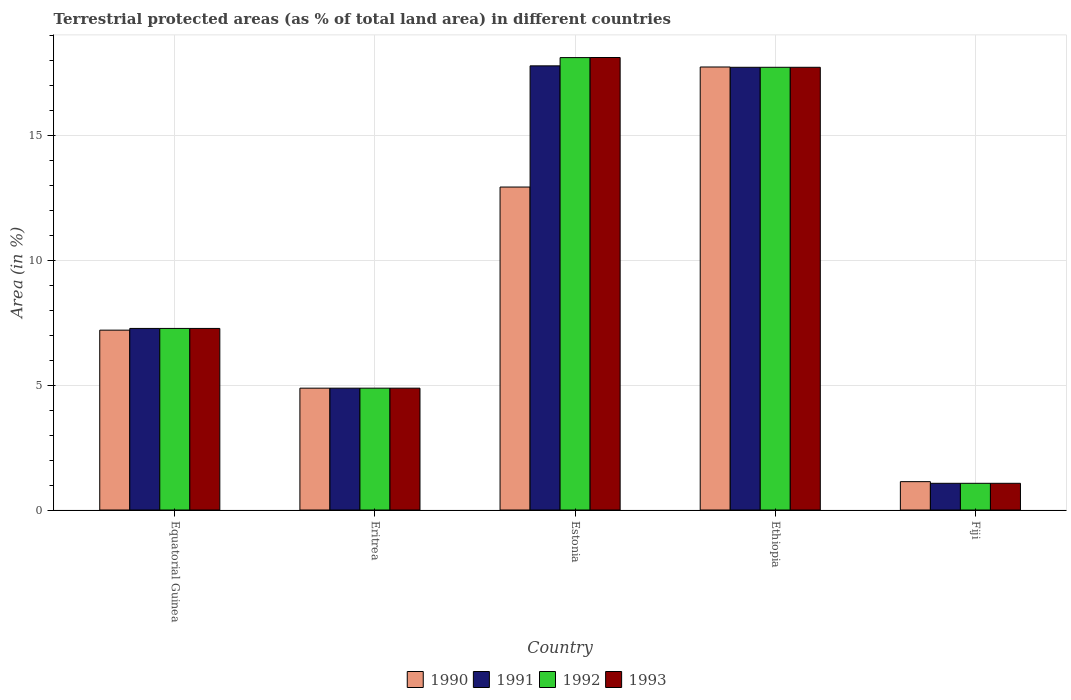How many groups of bars are there?
Offer a very short reply. 5. Are the number of bars on each tick of the X-axis equal?
Give a very brief answer. Yes. How many bars are there on the 4th tick from the left?
Keep it short and to the point. 4. What is the label of the 2nd group of bars from the left?
Your answer should be compact. Eritrea. In how many cases, is the number of bars for a given country not equal to the number of legend labels?
Provide a short and direct response. 0. What is the percentage of terrestrial protected land in 1992 in Eritrea?
Provide a succinct answer. 4.87. Across all countries, what is the maximum percentage of terrestrial protected land in 1990?
Offer a terse response. 17.72. Across all countries, what is the minimum percentage of terrestrial protected land in 1992?
Give a very brief answer. 1.07. In which country was the percentage of terrestrial protected land in 1990 maximum?
Keep it short and to the point. Ethiopia. In which country was the percentage of terrestrial protected land in 1993 minimum?
Your answer should be very brief. Fiji. What is the total percentage of terrestrial protected land in 1991 in the graph?
Your response must be concise. 48.68. What is the difference between the percentage of terrestrial protected land in 1991 in Eritrea and that in Ethiopia?
Your answer should be very brief. -12.84. What is the difference between the percentage of terrestrial protected land in 1992 in Ethiopia and the percentage of terrestrial protected land in 1993 in Fiji?
Offer a terse response. 16.64. What is the average percentage of terrestrial protected land in 1990 per country?
Provide a short and direct response. 8.77. What is the difference between the percentage of terrestrial protected land of/in 1991 and percentage of terrestrial protected land of/in 1993 in Fiji?
Ensure brevity in your answer.  0. What is the ratio of the percentage of terrestrial protected land in 1990 in Equatorial Guinea to that in Estonia?
Your answer should be very brief. 0.56. Is the percentage of terrestrial protected land in 1992 in Equatorial Guinea less than that in Ethiopia?
Give a very brief answer. Yes. What is the difference between the highest and the second highest percentage of terrestrial protected land in 1990?
Offer a terse response. 4.8. What is the difference between the highest and the lowest percentage of terrestrial protected land in 1990?
Ensure brevity in your answer.  16.59. Is the sum of the percentage of terrestrial protected land in 1991 in Estonia and Fiji greater than the maximum percentage of terrestrial protected land in 1992 across all countries?
Give a very brief answer. Yes. Is it the case that in every country, the sum of the percentage of terrestrial protected land in 1991 and percentage of terrestrial protected land in 1992 is greater than the sum of percentage of terrestrial protected land in 1993 and percentage of terrestrial protected land in 1990?
Ensure brevity in your answer.  No. What does the 1st bar from the left in Ethiopia represents?
Keep it short and to the point. 1990. Are all the bars in the graph horizontal?
Provide a short and direct response. No. What is the difference between two consecutive major ticks on the Y-axis?
Provide a succinct answer. 5. Are the values on the major ticks of Y-axis written in scientific E-notation?
Your response must be concise. No. Does the graph contain grids?
Offer a very short reply. Yes. Where does the legend appear in the graph?
Offer a terse response. Bottom center. How are the legend labels stacked?
Keep it short and to the point. Horizontal. What is the title of the graph?
Give a very brief answer. Terrestrial protected areas (as % of total land area) in different countries. Does "2004" appear as one of the legend labels in the graph?
Give a very brief answer. No. What is the label or title of the Y-axis?
Your answer should be compact. Area (in %). What is the Area (in %) of 1990 in Equatorial Guinea?
Provide a short and direct response. 7.19. What is the Area (in %) of 1991 in Equatorial Guinea?
Your answer should be very brief. 7.26. What is the Area (in %) of 1992 in Equatorial Guinea?
Your response must be concise. 7.26. What is the Area (in %) in 1993 in Equatorial Guinea?
Keep it short and to the point. 7.26. What is the Area (in %) of 1990 in Eritrea?
Offer a terse response. 4.87. What is the Area (in %) of 1991 in Eritrea?
Keep it short and to the point. 4.87. What is the Area (in %) of 1992 in Eritrea?
Keep it short and to the point. 4.87. What is the Area (in %) in 1993 in Eritrea?
Provide a succinct answer. 4.87. What is the Area (in %) of 1990 in Estonia?
Provide a short and direct response. 12.92. What is the Area (in %) in 1991 in Estonia?
Your answer should be very brief. 17.77. What is the Area (in %) in 1992 in Estonia?
Give a very brief answer. 18.1. What is the Area (in %) in 1993 in Estonia?
Your answer should be very brief. 18.1. What is the Area (in %) of 1990 in Ethiopia?
Your response must be concise. 17.72. What is the Area (in %) of 1991 in Ethiopia?
Ensure brevity in your answer.  17.71. What is the Area (in %) in 1992 in Ethiopia?
Your answer should be compact. 17.71. What is the Area (in %) in 1993 in Ethiopia?
Keep it short and to the point. 17.71. What is the Area (in %) of 1990 in Fiji?
Offer a very short reply. 1.13. What is the Area (in %) in 1991 in Fiji?
Give a very brief answer. 1.07. What is the Area (in %) of 1992 in Fiji?
Offer a very short reply. 1.07. What is the Area (in %) in 1993 in Fiji?
Your answer should be very brief. 1.07. Across all countries, what is the maximum Area (in %) in 1990?
Provide a short and direct response. 17.72. Across all countries, what is the maximum Area (in %) in 1991?
Provide a succinct answer. 17.77. Across all countries, what is the maximum Area (in %) of 1992?
Give a very brief answer. 18.1. Across all countries, what is the maximum Area (in %) of 1993?
Keep it short and to the point. 18.1. Across all countries, what is the minimum Area (in %) of 1990?
Your response must be concise. 1.13. Across all countries, what is the minimum Area (in %) in 1991?
Your answer should be compact. 1.07. Across all countries, what is the minimum Area (in %) in 1992?
Provide a short and direct response. 1.07. Across all countries, what is the minimum Area (in %) in 1993?
Provide a succinct answer. 1.07. What is the total Area (in %) in 1990 in the graph?
Provide a succinct answer. 43.85. What is the total Area (in %) in 1991 in the graph?
Offer a terse response. 48.68. What is the total Area (in %) of 1992 in the graph?
Your response must be concise. 49.01. What is the total Area (in %) of 1993 in the graph?
Your response must be concise. 49.02. What is the difference between the Area (in %) of 1990 in Equatorial Guinea and that in Eritrea?
Provide a short and direct response. 2.32. What is the difference between the Area (in %) in 1991 in Equatorial Guinea and that in Eritrea?
Offer a terse response. 2.39. What is the difference between the Area (in %) of 1992 in Equatorial Guinea and that in Eritrea?
Ensure brevity in your answer.  2.39. What is the difference between the Area (in %) in 1993 in Equatorial Guinea and that in Eritrea?
Provide a succinct answer. 2.39. What is the difference between the Area (in %) of 1990 in Equatorial Guinea and that in Estonia?
Your response must be concise. -5.73. What is the difference between the Area (in %) of 1991 in Equatorial Guinea and that in Estonia?
Your answer should be very brief. -10.5. What is the difference between the Area (in %) of 1992 in Equatorial Guinea and that in Estonia?
Your answer should be compact. -10.83. What is the difference between the Area (in %) in 1993 in Equatorial Guinea and that in Estonia?
Your answer should be compact. -10.84. What is the difference between the Area (in %) of 1990 in Equatorial Guinea and that in Ethiopia?
Ensure brevity in your answer.  -10.53. What is the difference between the Area (in %) in 1991 in Equatorial Guinea and that in Ethiopia?
Your answer should be very brief. -10.45. What is the difference between the Area (in %) of 1992 in Equatorial Guinea and that in Ethiopia?
Give a very brief answer. -10.45. What is the difference between the Area (in %) of 1993 in Equatorial Guinea and that in Ethiopia?
Offer a very short reply. -10.45. What is the difference between the Area (in %) of 1990 in Equatorial Guinea and that in Fiji?
Provide a succinct answer. 6.06. What is the difference between the Area (in %) of 1991 in Equatorial Guinea and that in Fiji?
Provide a short and direct response. 6.2. What is the difference between the Area (in %) in 1992 in Equatorial Guinea and that in Fiji?
Give a very brief answer. 6.2. What is the difference between the Area (in %) of 1993 in Equatorial Guinea and that in Fiji?
Ensure brevity in your answer.  6.2. What is the difference between the Area (in %) of 1990 in Eritrea and that in Estonia?
Keep it short and to the point. -8.05. What is the difference between the Area (in %) in 1991 in Eritrea and that in Estonia?
Provide a short and direct response. -12.89. What is the difference between the Area (in %) in 1992 in Eritrea and that in Estonia?
Provide a succinct answer. -13.22. What is the difference between the Area (in %) of 1993 in Eritrea and that in Estonia?
Your answer should be very brief. -13.23. What is the difference between the Area (in %) in 1990 in Eritrea and that in Ethiopia?
Offer a very short reply. -12.85. What is the difference between the Area (in %) of 1991 in Eritrea and that in Ethiopia?
Your response must be concise. -12.84. What is the difference between the Area (in %) of 1992 in Eritrea and that in Ethiopia?
Your answer should be very brief. -12.84. What is the difference between the Area (in %) in 1993 in Eritrea and that in Ethiopia?
Give a very brief answer. -12.84. What is the difference between the Area (in %) of 1990 in Eritrea and that in Fiji?
Offer a very short reply. 3.74. What is the difference between the Area (in %) of 1991 in Eritrea and that in Fiji?
Offer a terse response. 3.81. What is the difference between the Area (in %) of 1992 in Eritrea and that in Fiji?
Offer a terse response. 3.81. What is the difference between the Area (in %) of 1993 in Eritrea and that in Fiji?
Give a very brief answer. 3.81. What is the difference between the Area (in %) of 1990 in Estonia and that in Ethiopia?
Your response must be concise. -4.8. What is the difference between the Area (in %) in 1991 in Estonia and that in Ethiopia?
Your response must be concise. 0.06. What is the difference between the Area (in %) in 1992 in Estonia and that in Ethiopia?
Provide a short and direct response. 0.39. What is the difference between the Area (in %) of 1993 in Estonia and that in Ethiopia?
Offer a terse response. 0.39. What is the difference between the Area (in %) of 1990 in Estonia and that in Fiji?
Your response must be concise. 11.79. What is the difference between the Area (in %) in 1991 in Estonia and that in Fiji?
Provide a succinct answer. 16.7. What is the difference between the Area (in %) of 1992 in Estonia and that in Fiji?
Offer a very short reply. 17.03. What is the difference between the Area (in %) of 1993 in Estonia and that in Fiji?
Ensure brevity in your answer.  17.03. What is the difference between the Area (in %) in 1990 in Ethiopia and that in Fiji?
Ensure brevity in your answer.  16.59. What is the difference between the Area (in %) of 1991 in Ethiopia and that in Fiji?
Give a very brief answer. 16.64. What is the difference between the Area (in %) in 1992 in Ethiopia and that in Fiji?
Give a very brief answer. 16.64. What is the difference between the Area (in %) of 1993 in Ethiopia and that in Fiji?
Provide a short and direct response. 16.64. What is the difference between the Area (in %) of 1990 in Equatorial Guinea and the Area (in %) of 1991 in Eritrea?
Keep it short and to the point. 2.32. What is the difference between the Area (in %) of 1990 in Equatorial Guinea and the Area (in %) of 1992 in Eritrea?
Provide a short and direct response. 2.32. What is the difference between the Area (in %) of 1990 in Equatorial Guinea and the Area (in %) of 1993 in Eritrea?
Your response must be concise. 2.32. What is the difference between the Area (in %) in 1991 in Equatorial Guinea and the Area (in %) in 1992 in Eritrea?
Your answer should be compact. 2.39. What is the difference between the Area (in %) in 1991 in Equatorial Guinea and the Area (in %) in 1993 in Eritrea?
Keep it short and to the point. 2.39. What is the difference between the Area (in %) of 1992 in Equatorial Guinea and the Area (in %) of 1993 in Eritrea?
Make the answer very short. 2.39. What is the difference between the Area (in %) in 1990 in Equatorial Guinea and the Area (in %) in 1991 in Estonia?
Your answer should be compact. -10.57. What is the difference between the Area (in %) in 1990 in Equatorial Guinea and the Area (in %) in 1992 in Estonia?
Make the answer very short. -10.9. What is the difference between the Area (in %) in 1990 in Equatorial Guinea and the Area (in %) in 1993 in Estonia?
Provide a short and direct response. -10.91. What is the difference between the Area (in %) of 1991 in Equatorial Guinea and the Area (in %) of 1992 in Estonia?
Ensure brevity in your answer.  -10.83. What is the difference between the Area (in %) in 1991 in Equatorial Guinea and the Area (in %) in 1993 in Estonia?
Offer a terse response. -10.84. What is the difference between the Area (in %) of 1992 in Equatorial Guinea and the Area (in %) of 1993 in Estonia?
Ensure brevity in your answer.  -10.84. What is the difference between the Area (in %) in 1990 in Equatorial Guinea and the Area (in %) in 1991 in Ethiopia?
Your answer should be compact. -10.52. What is the difference between the Area (in %) of 1990 in Equatorial Guinea and the Area (in %) of 1992 in Ethiopia?
Keep it short and to the point. -10.52. What is the difference between the Area (in %) of 1990 in Equatorial Guinea and the Area (in %) of 1993 in Ethiopia?
Make the answer very short. -10.52. What is the difference between the Area (in %) of 1991 in Equatorial Guinea and the Area (in %) of 1992 in Ethiopia?
Provide a short and direct response. -10.45. What is the difference between the Area (in %) in 1991 in Equatorial Guinea and the Area (in %) in 1993 in Ethiopia?
Ensure brevity in your answer.  -10.45. What is the difference between the Area (in %) in 1992 in Equatorial Guinea and the Area (in %) in 1993 in Ethiopia?
Provide a short and direct response. -10.45. What is the difference between the Area (in %) in 1990 in Equatorial Guinea and the Area (in %) in 1991 in Fiji?
Ensure brevity in your answer.  6.13. What is the difference between the Area (in %) in 1990 in Equatorial Guinea and the Area (in %) in 1992 in Fiji?
Provide a short and direct response. 6.13. What is the difference between the Area (in %) in 1990 in Equatorial Guinea and the Area (in %) in 1993 in Fiji?
Make the answer very short. 6.13. What is the difference between the Area (in %) of 1991 in Equatorial Guinea and the Area (in %) of 1992 in Fiji?
Provide a short and direct response. 6.2. What is the difference between the Area (in %) of 1991 in Equatorial Guinea and the Area (in %) of 1993 in Fiji?
Your answer should be very brief. 6.2. What is the difference between the Area (in %) in 1992 in Equatorial Guinea and the Area (in %) in 1993 in Fiji?
Give a very brief answer. 6.2. What is the difference between the Area (in %) in 1990 in Eritrea and the Area (in %) in 1991 in Estonia?
Your answer should be compact. -12.89. What is the difference between the Area (in %) of 1990 in Eritrea and the Area (in %) of 1992 in Estonia?
Make the answer very short. -13.22. What is the difference between the Area (in %) in 1990 in Eritrea and the Area (in %) in 1993 in Estonia?
Keep it short and to the point. -13.23. What is the difference between the Area (in %) of 1991 in Eritrea and the Area (in %) of 1992 in Estonia?
Your answer should be compact. -13.22. What is the difference between the Area (in %) of 1991 in Eritrea and the Area (in %) of 1993 in Estonia?
Provide a succinct answer. -13.23. What is the difference between the Area (in %) of 1992 in Eritrea and the Area (in %) of 1993 in Estonia?
Ensure brevity in your answer.  -13.23. What is the difference between the Area (in %) in 1990 in Eritrea and the Area (in %) in 1991 in Ethiopia?
Make the answer very short. -12.84. What is the difference between the Area (in %) of 1990 in Eritrea and the Area (in %) of 1992 in Ethiopia?
Your answer should be compact. -12.84. What is the difference between the Area (in %) in 1990 in Eritrea and the Area (in %) in 1993 in Ethiopia?
Provide a succinct answer. -12.84. What is the difference between the Area (in %) of 1991 in Eritrea and the Area (in %) of 1992 in Ethiopia?
Ensure brevity in your answer.  -12.84. What is the difference between the Area (in %) of 1991 in Eritrea and the Area (in %) of 1993 in Ethiopia?
Your response must be concise. -12.84. What is the difference between the Area (in %) in 1992 in Eritrea and the Area (in %) in 1993 in Ethiopia?
Ensure brevity in your answer.  -12.84. What is the difference between the Area (in %) in 1990 in Eritrea and the Area (in %) in 1991 in Fiji?
Keep it short and to the point. 3.81. What is the difference between the Area (in %) in 1990 in Eritrea and the Area (in %) in 1992 in Fiji?
Keep it short and to the point. 3.81. What is the difference between the Area (in %) in 1990 in Eritrea and the Area (in %) in 1993 in Fiji?
Ensure brevity in your answer.  3.81. What is the difference between the Area (in %) in 1991 in Eritrea and the Area (in %) in 1992 in Fiji?
Make the answer very short. 3.81. What is the difference between the Area (in %) in 1991 in Eritrea and the Area (in %) in 1993 in Fiji?
Your response must be concise. 3.81. What is the difference between the Area (in %) in 1992 in Eritrea and the Area (in %) in 1993 in Fiji?
Keep it short and to the point. 3.81. What is the difference between the Area (in %) of 1990 in Estonia and the Area (in %) of 1991 in Ethiopia?
Offer a terse response. -4.79. What is the difference between the Area (in %) of 1990 in Estonia and the Area (in %) of 1992 in Ethiopia?
Your answer should be very brief. -4.79. What is the difference between the Area (in %) of 1990 in Estonia and the Area (in %) of 1993 in Ethiopia?
Ensure brevity in your answer.  -4.79. What is the difference between the Area (in %) in 1991 in Estonia and the Area (in %) in 1992 in Ethiopia?
Your answer should be very brief. 0.06. What is the difference between the Area (in %) in 1991 in Estonia and the Area (in %) in 1993 in Ethiopia?
Ensure brevity in your answer.  0.06. What is the difference between the Area (in %) of 1992 in Estonia and the Area (in %) of 1993 in Ethiopia?
Provide a succinct answer. 0.39. What is the difference between the Area (in %) in 1990 in Estonia and the Area (in %) in 1991 in Fiji?
Offer a terse response. 11.85. What is the difference between the Area (in %) in 1990 in Estonia and the Area (in %) in 1992 in Fiji?
Your answer should be compact. 11.85. What is the difference between the Area (in %) of 1990 in Estonia and the Area (in %) of 1993 in Fiji?
Your answer should be compact. 11.85. What is the difference between the Area (in %) in 1991 in Estonia and the Area (in %) in 1992 in Fiji?
Provide a succinct answer. 16.7. What is the difference between the Area (in %) of 1991 in Estonia and the Area (in %) of 1993 in Fiji?
Your answer should be compact. 16.7. What is the difference between the Area (in %) in 1992 in Estonia and the Area (in %) in 1993 in Fiji?
Offer a terse response. 17.03. What is the difference between the Area (in %) of 1990 in Ethiopia and the Area (in %) of 1991 in Fiji?
Offer a very short reply. 16.65. What is the difference between the Area (in %) in 1990 in Ethiopia and the Area (in %) in 1992 in Fiji?
Ensure brevity in your answer.  16.65. What is the difference between the Area (in %) in 1990 in Ethiopia and the Area (in %) in 1993 in Fiji?
Your answer should be compact. 16.65. What is the difference between the Area (in %) in 1991 in Ethiopia and the Area (in %) in 1992 in Fiji?
Ensure brevity in your answer.  16.64. What is the difference between the Area (in %) in 1991 in Ethiopia and the Area (in %) in 1993 in Fiji?
Keep it short and to the point. 16.64. What is the difference between the Area (in %) of 1992 in Ethiopia and the Area (in %) of 1993 in Fiji?
Give a very brief answer. 16.64. What is the average Area (in %) in 1990 per country?
Offer a terse response. 8.77. What is the average Area (in %) in 1991 per country?
Keep it short and to the point. 9.74. What is the average Area (in %) in 1992 per country?
Ensure brevity in your answer.  9.8. What is the average Area (in %) in 1993 per country?
Ensure brevity in your answer.  9.8. What is the difference between the Area (in %) of 1990 and Area (in %) of 1991 in Equatorial Guinea?
Offer a very short reply. -0.07. What is the difference between the Area (in %) of 1990 and Area (in %) of 1992 in Equatorial Guinea?
Offer a terse response. -0.07. What is the difference between the Area (in %) in 1990 and Area (in %) in 1993 in Equatorial Guinea?
Provide a succinct answer. -0.07. What is the difference between the Area (in %) of 1990 and Area (in %) of 1991 in Eritrea?
Provide a short and direct response. 0. What is the difference between the Area (in %) of 1990 and Area (in %) of 1992 in Eritrea?
Make the answer very short. 0. What is the difference between the Area (in %) of 1991 and Area (in %) of 1993 in Eritrea?
Provide a short and direct response. 0. What is the difference between the Area (in %) of 1992 and Area (in %) of 1993 in Eritrea?
Keep it short and to the point. 0. What is the difference between the Area (in %) in 1990 and Area (in %) in 1991 in Estonia?
Keep it short and to the point. -4.85. What is the difference between the Area (in %) in 1990 and Area (in %) in 1992 in Estonia?
Provide a succinct answer. -5.18. What is the difference between the Area (in %) of 1990 and Area (in %) of 1993 in Estonia?
Offer a terse response. -5.18. What is the difference between the Area (in %) of 1991 and Area (in %) of 1992 in Estonia?
Your answer should be compact. -0.33. What is the difference between the Area (in %) of 1991 and Area (in %) of 1993 in Estonia?
Provide a succinct answer. -0.33. What is the difference between the Area (in %) in 1992 and Area (in %) in 1993 in Estonia?
Your answer should be compact. -0. What is the difference between the Area (in %) in 1990 and Area (in %) in 1991 in Ethiopia?
Your response must be concise. 0.01. What is the difference between the Area (in %) of 1990 and Area (in %) of 1992 in Ethiopia?
Give a very brief answer. 0.01. What is the difference between the Area (in %) of 1990 and Area (in %) of 1993 in Ethiopia?
Offer a terse response. 0.01. What is the difference between the Area (in %) in 1991 and Area (in %) in 1993 in Ethiopia?
Offer a terse response. 0. What is the difference between the Area (in %) in 1992 and Area (in %) in 1993 in Ethiopia?
Your answer should be compact. 0. What is the difference between the Area (in %) in 1990 and Area (in %) in 1991 in Fiji?
Keep it short and to the point. 0.07. What is the difference between the Area (in %) of 1990 and Area (in %) of 1992 in Fiji?
Make the answer very short. 0.07. What is the difference between the Area (in %) in 1990 and Area (in %) in 1993 in Fiji?
Give a very brief answer. 0.07. What is the difference between the Area (in %) of 1991 and Area (in %) of 1993 in Fiji?
Offer a very short reply. 0. What is the ratio of the Area (in %) in 1990 in Equatorial Guinea to that in Eritrea?
Provide a succinct answer. 1.48. What is the ratio of the Area (in %) of 1991 in Equatorial Guinea to that in Eritrea?
Provide a short and direct response. 1.49. What is the ratio of the Area (in %) in 1992 in Equatorial Guinea to that in Eritrea?
Offer a terse response. 1.49. What is the ratio of the Area (in %) in 1993 in Equatorial Guinea to that in Eritrea?
Your response must be concise. 1.49. What is the ratio of the Area (in %) in 1990 in Equatorial Guinea to that in Estonia?
Ensure brevity in your answer.  0.56. What is the ratio of the Area (in %) in 1991 in Equatorial Guinea to that in Estonia?
Ensure brevity in your answer.  0.41. What is the ratio of the Area (in %) in 1992 in Equatorial Guinea to that in Estonia?
Make the answer very short. 0.4. What is the ratio of the Area (in %) in 1993 in Equatorial Guinea to that in Estonia?
Provide a succinct answer. 0.4. What is the ratio of the Area (in %) in 1990 in Equatorial Guinea to that in Ethiopia?
Provide a short and direct response. 0.41. What is the ratio of the Area (in %) in 1991 in Equatorial Guinea to that in Ethiopia?
Provide a short and direct response. 0.41. What is the ratio of the Area (in %) in 1992 in Equatorial Guinea to that in Ethiopia?
Offer a very short reply. 0.41. What is the ratio of the Area (in %) in 1993 in Equatorial Guinea to that in Ethiopia?
Your answer should be compact. 0.41. What is the ratio of the Area (in %) of 1990 in Equatorial Guinea to that in Fiji?
Offer a very short reply. 6.34. What is the ratio of the Area (in %) of 1991 in Equatorial Guinea to that in Fiji?
Ensure brevity in your answer.  6.8. What is the ratio of the Area (in %) of 1992 in Equatorial Guinea to that in Fiji?
Provide a succinct answer. 6.8. What is the ratio of the Area (in %) of 1993 in Equatorial Guinea to that in Fiji?
Ensure brevity in your answer.  6.8. What is the ratio of the Area (in %) in 1990 in Eritrea to that in Estonia?
Provide a succinct answer. 0.38. What is the ratio of the Area (in %) of 1991 in Eritrea to that in Estonia?
Provide a succinct answer. 0.27. What is the ratio of the Area (in %) of 1992 in Eritrea to that in Estonia?
Provide a short and direct response. 0.27. What is the ratio of the Area (in %) in 1993 in Eritrea to that in Estonia?
Provide a short and direct response. 0.27. What is the ratio of the Area (in %) of 1990 in Eritrea to that in Ethiopia?
Your response must be concise. 0.28. What is the ratio of the Area (in %) of 1991 in Eritrea to that in Ethiopia?
Your answer should be very brief. 0.28. What is the ratio of the Area (in %) in 1992 in Eritrea to that in Ethiopia?
Your response must be concise. 0.28. What is the ratio of the Area (in %) in 1993 in Eritrea to that in Ethiopia?
Your response must be concise. 0.28. What is the ratio of the Area (in %) of 1990 in Eritrea to that in Fiji?
Make the answer very short. 4.3. What is the ratio of the Area (in %) in 1991 in Eritrea to that in Fiji?
Your answer should be very brief. 4.56. What is the ratio of the Area (in %) of 1992 in Eritrea to that in Fiji?
Offer a terse response. 4.56. What is the ratio of the Area (in %) of 1993 in Eritrea to that in Fiji?
Give a very brief answer. 4.56. What is the ratio of the Area (in %) in 1990 in Estonia to that in Ethiopia?
Give a very brief answer. 0.73. What is the ratio of the Area (in %) of 1992 in Estonia to that in Ethiopia?
Provide a succinct answer. 1.02. What is the ratio of the Area (in %) in 1993 in Estonia to that in Ethiopia?
Give a very brief answer. 1.02. What is the ratio of the Area (in %) of 1990 in Estonia to that in Fiji?
Ensure brevity in your answer.  11.39. What is the ratio of the Area (in %) of 1991 in Estonia to that in Fiji?
Provide a succinct answer. 16.64. What is the ratio of the Area (in %) in 1992 in Estonia to that in Fiji?
Your answer should be very brief. 16.95. What is the ratio of the Area (in %) in 1993 in Estonia to that in Fiji?
Make the answer very short. 16.95. What is the ratio of the Area (in %) in 1990 in Ethiopia to that in Fiji?
Offer a very short reply. 15.62. What is the ratio of the Area (in %) in 1991 in Ethiopia to that in Fiji?
Keep it short and to the point. 16.58. What is the ratio of the Area (in %) in 1992 in Ethiopia to that in Fiji?
Your response must be concise. 16.58. What is the ratio of the Area (in %) of 1993 in Ethiopia to that in Fiji?
Your response must be concise. 16.58. What is the difference between the highest and the second highest Area (in %) in 1990?
Make the answer very short. 4.8. What is the difference between the highest and the second highest Area (in %) of 1991?
Offer a terse response. 0.06. What is the difference between the highest and the second highest Area (in %) in 1992?
Offer a very short reply. 0.39. What is the difference between the highest and the second highest Area (in %) in 1993?
Make the answer very short. 0.39. What is the difference between the highest and the lowest Area (in %) of 1990?
Provide a succinct answer. 16.59. What is the difference between the highest and the lowest Area (in %) of 1992?
Keep it short and to the point. 17.03. What is the difference between the highest and the lowest Area (in %) in 1993?
Give a very brief answer. 17.03. 